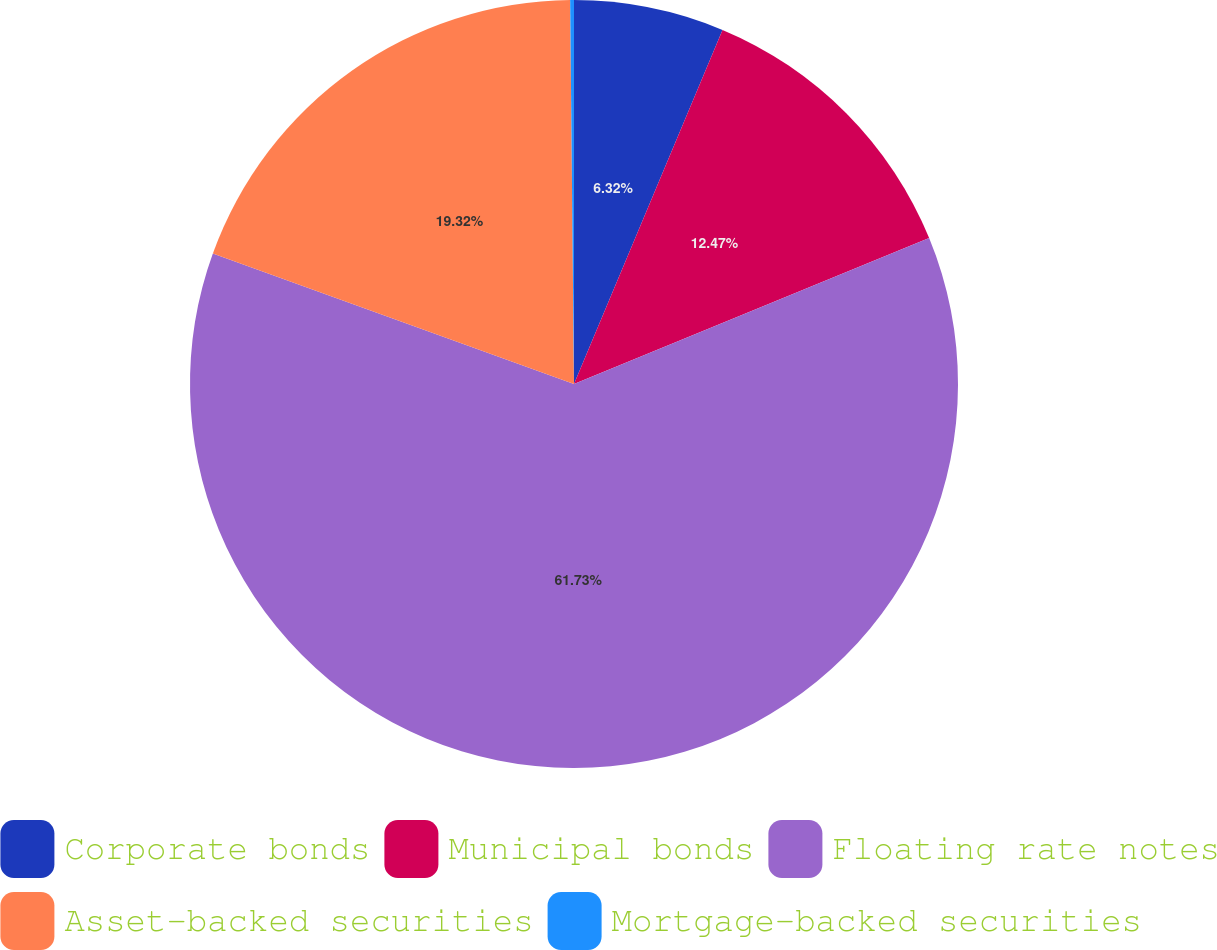Convert chart to OTSL. <chart><loc_0><loc_0><loc_500><loc_500><pie_chart><fcel>Corporate bonds<fcel>Municipal bonds<fcel>Floating rate notes<fcel>Asset-backed securities<fcel>Mortgage-backed securities<nl><fcel>6.32%<fcel>12.47%<fcel>61.72%<fcel>19.32%<fcel>0.16%<nl></chart> 